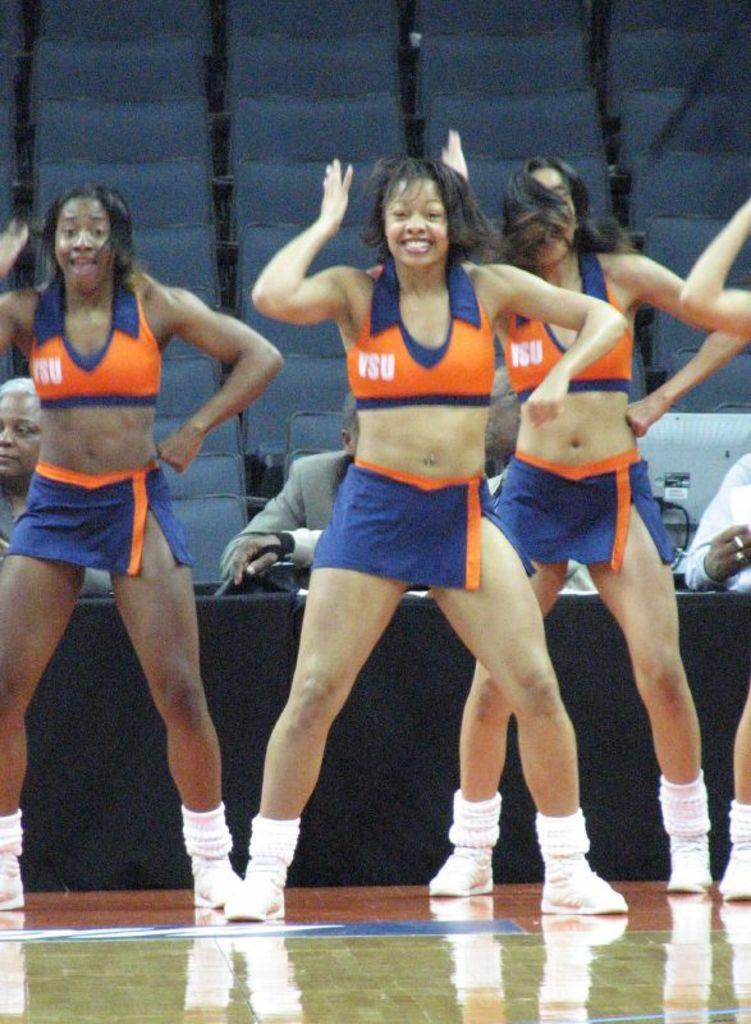<image>
Write a terse but informative summary of the picture. The cheerleaders at VSU wear orange and blue. 